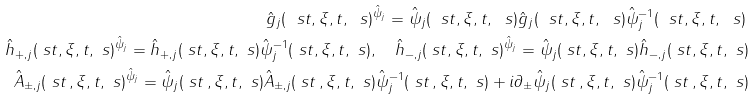Convert formula to latex. <formula><loc_0><loc_0><loc_500><loc_500>\hat { g } _ { j } ( \ s t , \xi , t , \ s ) ^ { \hat { \psi } _ { j } } = \hat { \psi } _ { j } ( \ s t , \xi , t , \ s ) \hat { g } _ { j } ( \ s t , \xi , t , \ s ) \hat { \psi } _ { j } ^ { - 1 } ( \ s t , \xi , t , \ s ) \, \\ \hat { h } _ { + , j } ( \ s t , \xi , t , \ s ) ^ { \hat { \psi } _ { j } } = \hat { h } _ { + , j } ( \ s t , \xi , t , \ s ) \hat { \psi } _ { j } ^ { - 1 } ( \ s t , \xi , t , \ s ) , \quad \hat { h } _ { - , j } ( \ s t , \xi , t , \ s ) ^ { \hat { \psi } _ { j } } = \hat { \psi } _ { j } ( \ s t , \xi , t , \ s ) \hat { h } _ { - , j } ( \ s t , \xi , t , \ s ) \\ \hat { A } _ { \pm , j } ( \ s t \, , \xi , t , \ s ) ^ { \hat { \psi } _ { j } } = \hat { \psi } _ { j } ( \ s t \, , \xi , t , \ s ) \hat { A } _ { \pm , j } ( \ s t \, , \xi , t , \ s ) \hat { \psi } _ { j } ^ { - 1 } ( \ s t \, , \xi , t , \ s ) + i \partial _ { \pm } \hat { \psi } _ { j } ( \ s t \, , \xi , t , \ s ) \hat { \psi } ^ { - 1 } _ { j } ( \ s t \, , \xi , t , \ s )</formula> 